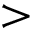Convert formula to latex. <formula><loc_0><loc_0><loc_500><loc_500>></formula> 